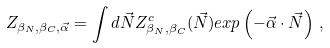Convert formula to latex. <formula><loc_0><loc_0><loc_500><loc_500>Z _ { \beta _ { N } , \beta _ { C } , \vec { \alpha } } = \int d \vec { N } Z ^ { c } _ { \beta _ { N } , \beta _ { C } } ( \vec { N } ) e x p \left ( - \vec { \alpha } \cdot \vec { N } \right ) \, ,</formula> 